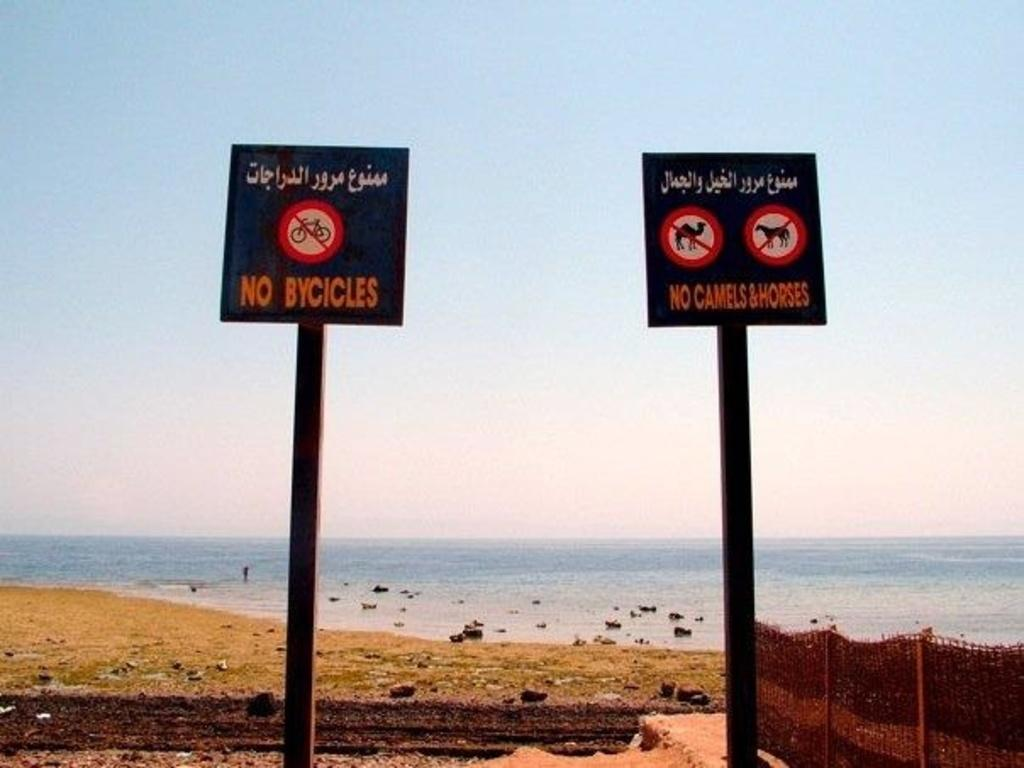<image>
Write a terse but informative summary of the picture. A sign has the words no bicycles and is near the beach. 